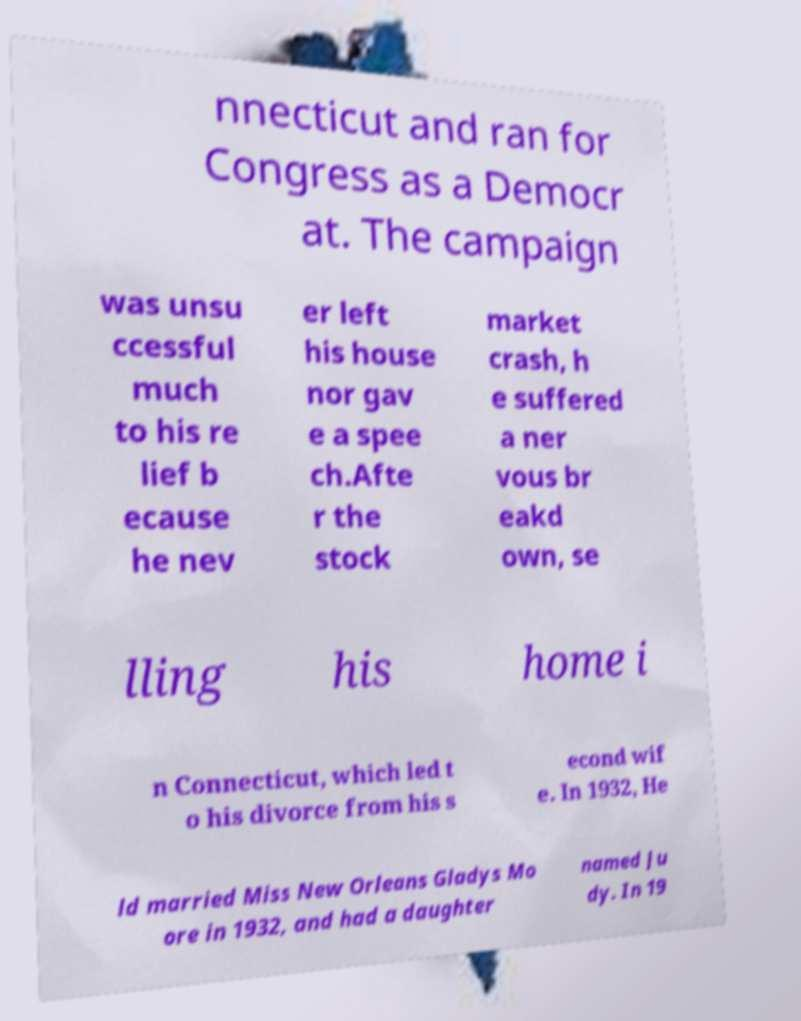Please identify and transcribe the text found in this image. nnecticut and ran for Congress as a Democr at. The campaign was unsu ccessful much to his re lief b ecause he nev er left his house nor gav e a spee ch.Afte r the stock market crash, h e suffered a ner vous br eakd own, se lling his home i n Connecticut, which led t o his divorce from his s econd wif e. In 1932, He ld married Miss New Orleans Gladys Mo ore in 1932, and had a daughter named Ju dy. In 19 